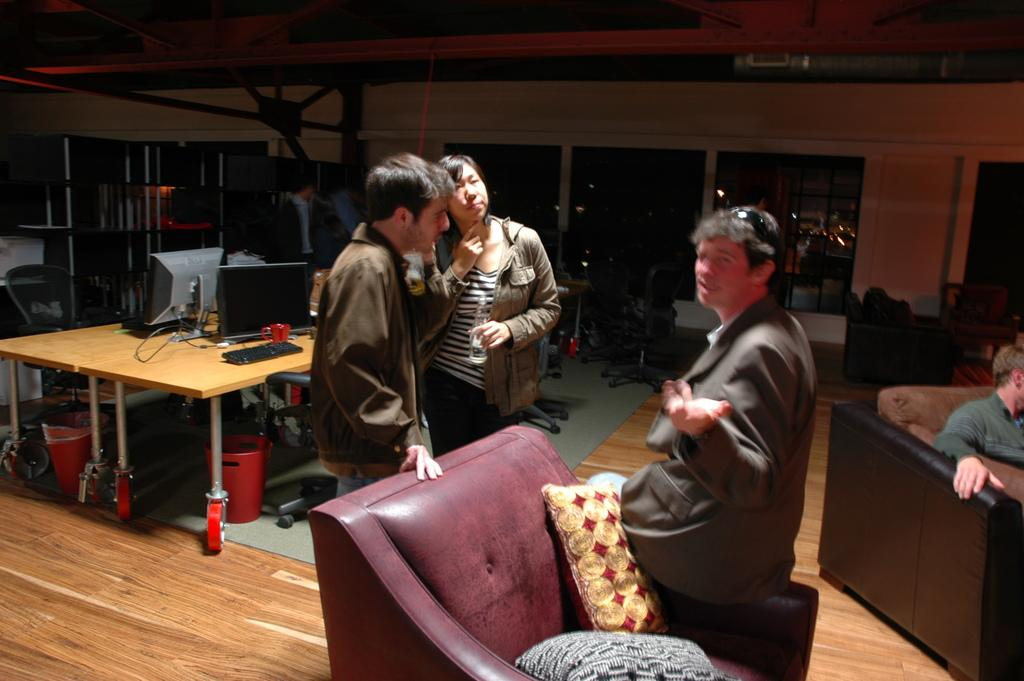What is the setting of the image? The image is inside a room. Who or what can be seen in the image? There is a group of people in the image. What electronic device is present in the image? There is a computer in the image. What is used for typing on the computer? There is a keyboard in the image. What can be seen on the table in the image? There are wires on the table in the image. What is at the bottom of the image? There is a mat at the bottom of the image. What is the opinion of the quarter on the computer's performance? There is no quarter present in the image, and therefore no opinion can be attributed to it. 